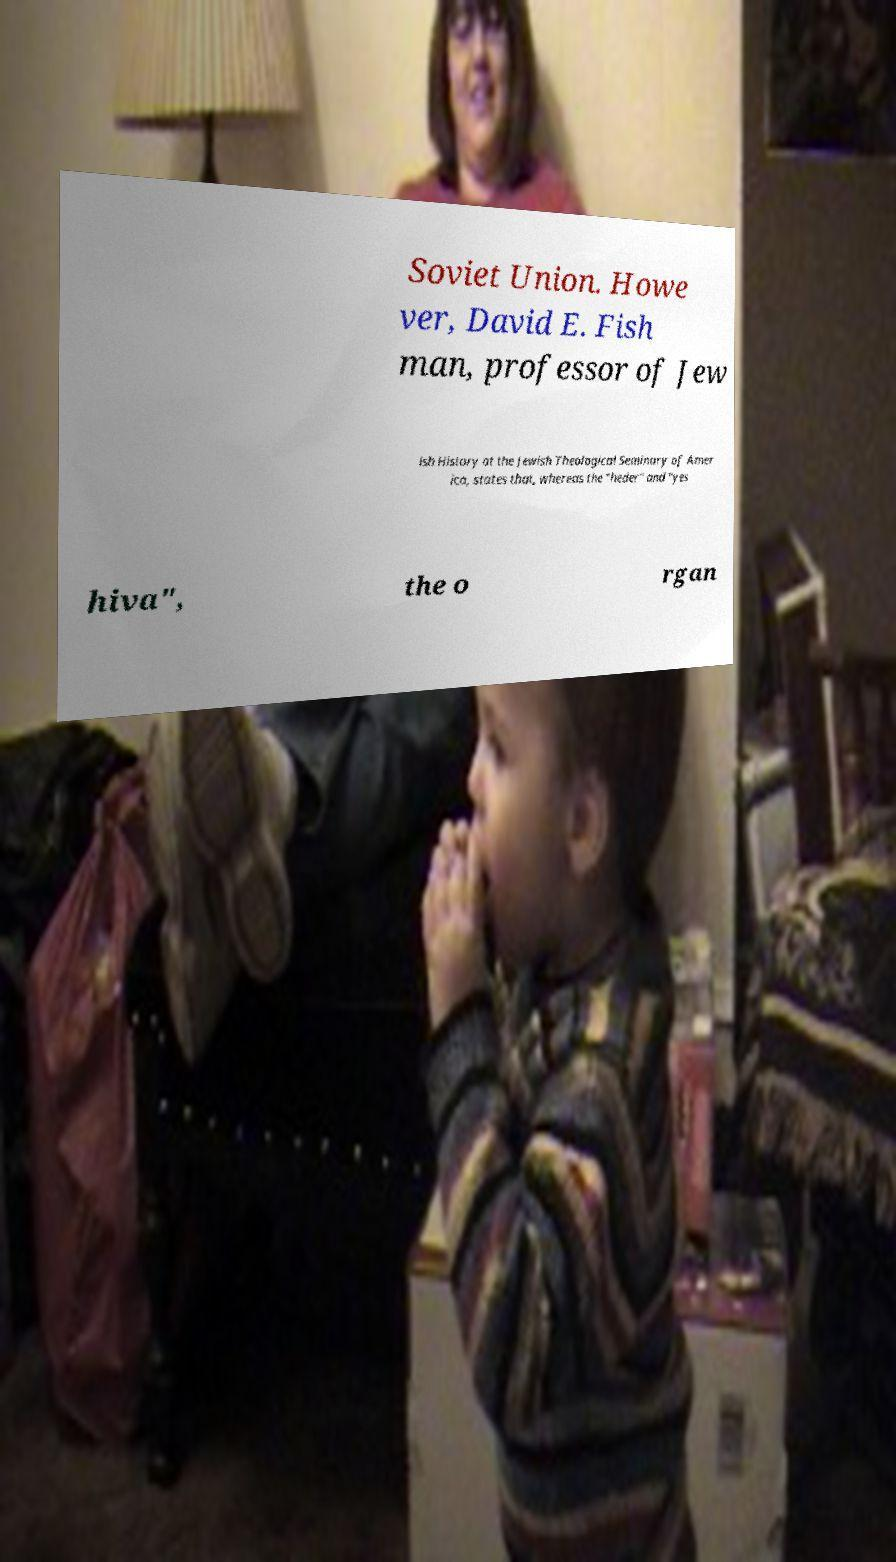Could you assist in decoding the text presented in this image and type it out clearly? Soviet Union. Howe ver, David E. Fish man, professor of Jew ish History at the Jewish Theological Seminary of Amer ica, states that, whereas the "heder" and "yes hiva", the o rgan 